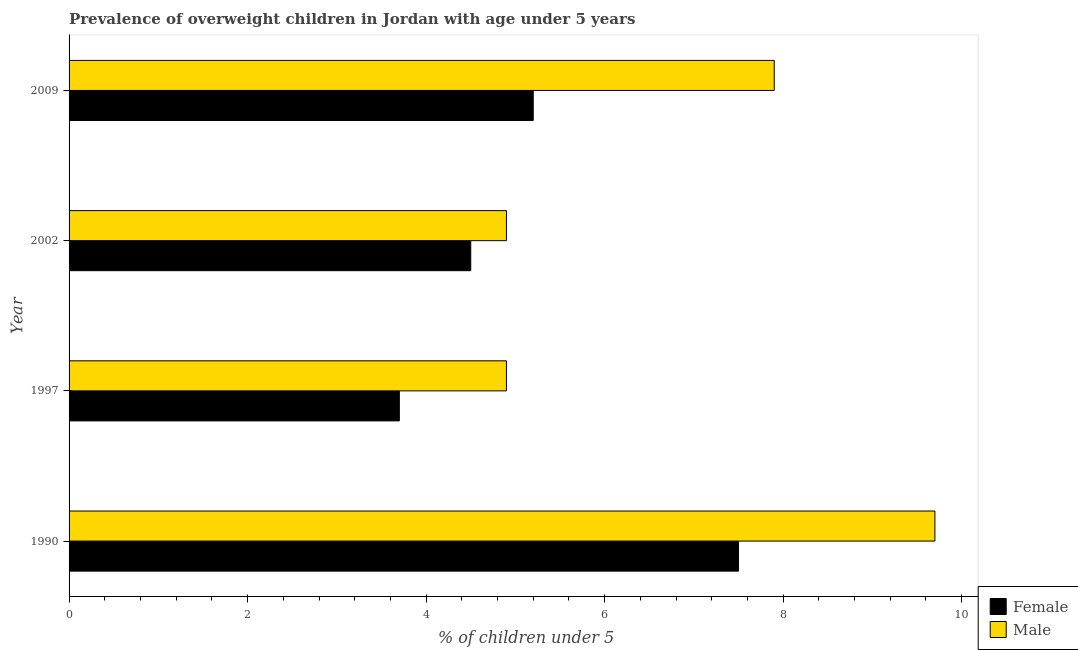How many different coloured bars are there?
Provide a succinct answer. 2. Are the number of bars on each tick of the Y-axis equal?
Your response must be concise. Yes. What is the label of the 2nd group of bars from the top?
Your answer should be compact. 2002. What is the percentage of obese male children in 1997?
Provide a succinct answer. 4.9. Across all years, what is the maximum percentage of obese male children?
Ensure brevity in your answer.  9.7. Across all years, what is the minimum percentage of obese female children?
Give a very brief answer. 3.7. In which year was the percentage of obese female children maximum?
Your answer should be very brief. 1990. In which year was the percentage of obese male children minimum?
Provide a short and direct response. 1997. What is the total percentage of obese female children in the graph?
Make the answer very short. 20.9. What is the difference between the percentage of obese female children in 2002 and the percentage of obese male children in 1997?
Your answer should be very brief. -0.4. What is the average percentage of obese female children per year?
Offer a terse response. 5.22. In the year 2002, what is the difference between the percentage of obese female children and percentage of obese male children?
Your response must be concise. -0.4. In how many years, is the percentage of obese female children greater than 3.6 %?
Make the answer very short. 4. What is the ratio of the percentage of obese female children in 1997 to that in 2002?
Ensure brevity in your answer.  0.82. Is the percentage of obese male children in 1990 less than that in 1997?
Offer a terse response. No. What is the difference between the highest and the lowest percentage of obese female children?
Offer a terse response. 3.8. In how many years, is the percentage of obese female children greater than the average percentage of obese female children taken over all years?
Your answer should be very brief. 1. How many bars are there?
Your answer should be compact. 8. What is the difference between two consecutive major ticks on the X-axis?
Your response must be concise. 2. Does the graph contain grids?
Offer a terse response. No. How many legend labels are there?
Your response must be concise. 2. What is the title of the graph?
Make the answer very short. Prevalence of overweight children in Jordan with age under 5 years. Does "Female labor force" appear as one of the legend labels in the graph?
Your response must be concise. No. What is the label or title of the X-axis?
Provide a short and direct response.  % of children under 5. What is the label or title of the Y-axis?
Your response must be concise. Year. What is the  % of children under 5 in Male in 1990?
Offer a terse response. 9.7. What is the  % of children under 5 of Female in 1997?
Make the answer very short. 3.7. What is the  % of children under 5 of Male in 1997?
Your answer should be very brief. 4.9. What is the  % of children under 5 in Male in 2002?
Make the answer very short. 4.9. What is the  % of children under 5 of Female in 2009?
Offer a very short reply. 5.2. What is the  % of children under 5 in Male in 2009?
Your answer should be compact. 7.9. Across all years, what is the maximum  % of children under 5 of Male?
Provide a succinct answer. 9.7. Across all years, what is the minimum  % of children under 5 in Female?
Your answer should be compact. 3.7. Across all years, what is the minimum  % of children under 5 in Male?
Your response must be concise. 4.9. What is the total  % of children under 5 of Female in the graph?
Provide a short and direct response. 20.9. What is the total  % of children under 5 in Male in the graph?
Make the answer very short. 27.4. What is the difference between the  % of children under 5 in Female in 1990 and that in 1997?
Ensure brevity in your answer.  3.8. What is the difference between the  % of children under 5 of Male in 1990 and that in 1997?
Your answer should be very brief. 4.8. What is the difference between the  % of children under 5 in Female in 1990 and that in 2009?
Provide a succinct answer. 2.3. What is the difference between the  % of children under 5 in Female in 2002 and that in 2009?
Your answer should be very brief. -0.7. What is the difference between the  % of children under 5 in Female in 1990 and the  % of children under 5 in Male in 1997?
Offer a terse response. 2.6. What is the difference between the  % of children under 5 in Female in 1990 and the  % of children under 5 in Male in 2009?
Your answer should be very brief. -0.4. What is the difference between the  % of children under 5 in Female in 1997 and the  % of children under 5 in Male in 2009?
Ensure brevity in your answer.  -4.2. What is the difference between the  % of children under 5 of Female in 2002 and the  % of children under 5 of Male in 2009?
Ensure brevity in your answer.  -3.4. What is the average  % of children under 5 of Female per year?
Ensure brevity in your answer.  5.22. What is the average  % of children under 5 in Male per year?
Your answer should be very brief. 6.85. In the year 1990, what is the difference between the  % of children under 5 in Female and  % of children under 5 in Male?
Ensure brevity in your answer.  -2.2. In the year 2002, what is the difference between the  % of children under 5 in Female and  % of children under 5 in Male?
Provide a succinct answer. -0.4. In the year 2009, what is the difference between the  % of children under 5 in Female and  % of children under 5 in Male?
Make the answer very short. -2.7. What is the ratio of the  % of children under 5 in Female in 1990 to that in 1997?
Provide a short and direct response. 2.03. What is the ratio of the  % of children under 5 in Male in 1990 to that in 1997?
Keep it short and to the point. 1.98. What is the ratio of the  % of children under 5 of Male in 1990 to that in 2002?
Keep it short and to the point. 1.98. What is the ratio of the  % of children under 5 of Female in 1990 to that in 2009?
Your response must be concise. 1.44. What is the ratio of the  % of children under 5 of Male in 1990 to that in 2009?
Ensure brevity in your answer.  1.23. What is the ratio of the  % of children under 5 of Female in 1997 to that in 2002?
Offer a terse response. 0.82. What is the ratio of the  % of children under 5 of Male in 1997 to that in 2002?
Give a very brief answer. 1. What is the ratio of the  % of children under 5 of Female in 1997 to that in 2009?
Your response must be concise. 0.71. What is the ratio of the  % of children under 5 of Male in 1997 to that in 2009?
Provide a short and direct response. 0.62. What is the ratio of the  % of children under 5 in Female in 2002 to that in 2009?
Provide a short and direct response. 0.87. What is the ratio of the  % of children under 5 in Male in 2002 to that in 2009?
Your answer should be very brief. 0.62. What is the difference between the highest and the second highest  % of children under 5 of Female?
Your response must be concise. 2.3. What is the difference between the highest and the lowest  % of children under 5 in Female?
Provide a short and direct response. 3.8. What is the difference between the highest and the lowest  % of children under 5 of Male?
Keep it short and to the point. 4.8. 